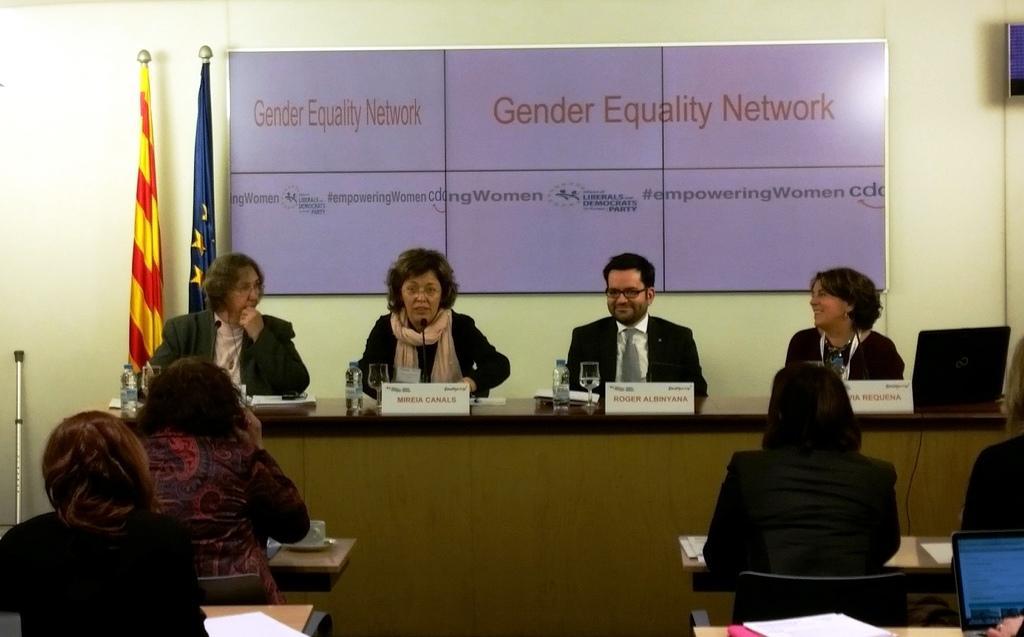Please provide a concise description of this image. In the foreground of the picture there are people, tables, papers, name plates, bottles, glasses, cup and laptops. In the background we can see board, flags and wall. On the right there is a black color object. On the left it looks like an iron stick. 